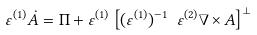Convert formula to latex. <formula><loc_0><loc_0><loc_500><loc_500>\varepsilon ^ { ( 1 ) } { \dot { A } } = { \Pi } + \varepsilon ^ { ( 1 ) } \left [ ( \varepsilon ^ { ( 1 ) } ) ^ { - 1 } \ \varepsilon ^ { ( 2 ) } \nabla \times { A } \right ] ^ { \bot }</formula> 